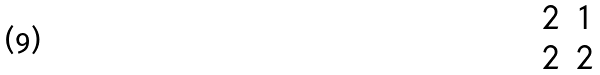<formula> <loc_0><loc_0><loc_500><loc_500>\begin{matrix} 2 & 1 \\ 2 & 2 \end{matrix}</formula> 